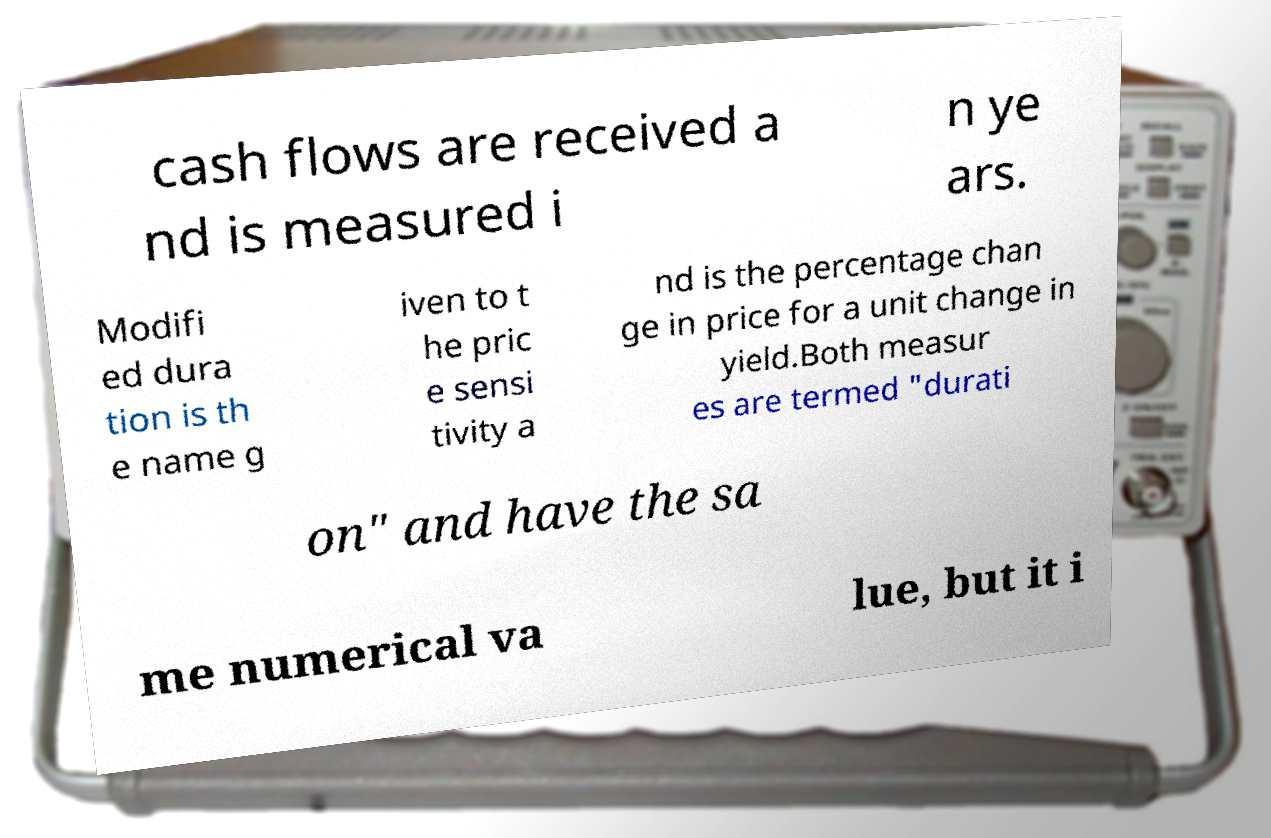For documentation purposes, I need the text within this image transcribed. Could you provide that? cash flows are received a nd is measured i n ye ars. Modifi ed dura tion is th e name g iven to t he pric e sensi tivity a nd is the percentage chan ge in price for a unit change in yield.Both measur es are termed "durati on" and have the sa me numerical va lue, but it i 